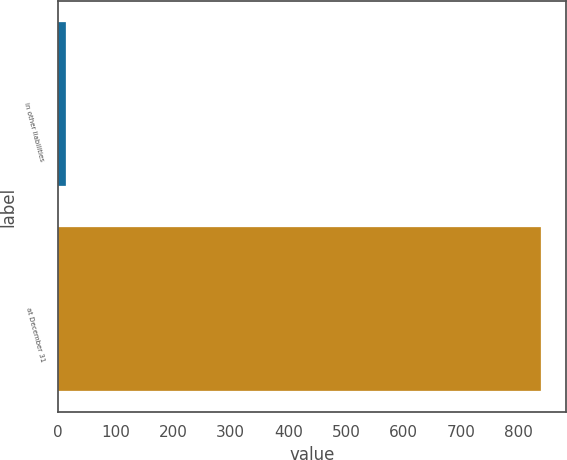Convert chart. <chart><loc_0><loc_0><loc_500><loc_500><bar_chart><fcel>in other liabilities<fcel>at December 31<nl><fcel>14<fcel>840<nl></chart> 